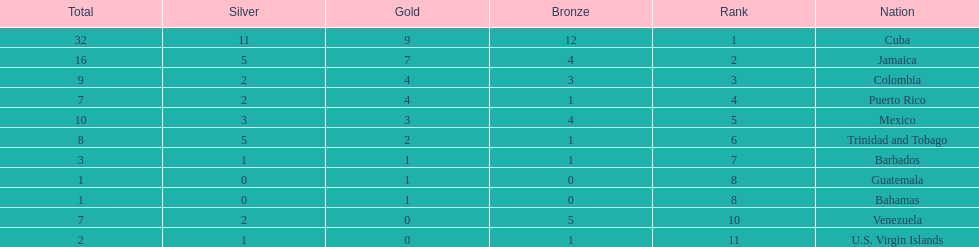Who had more silvers? colmbia or the bahamas Colombia. 